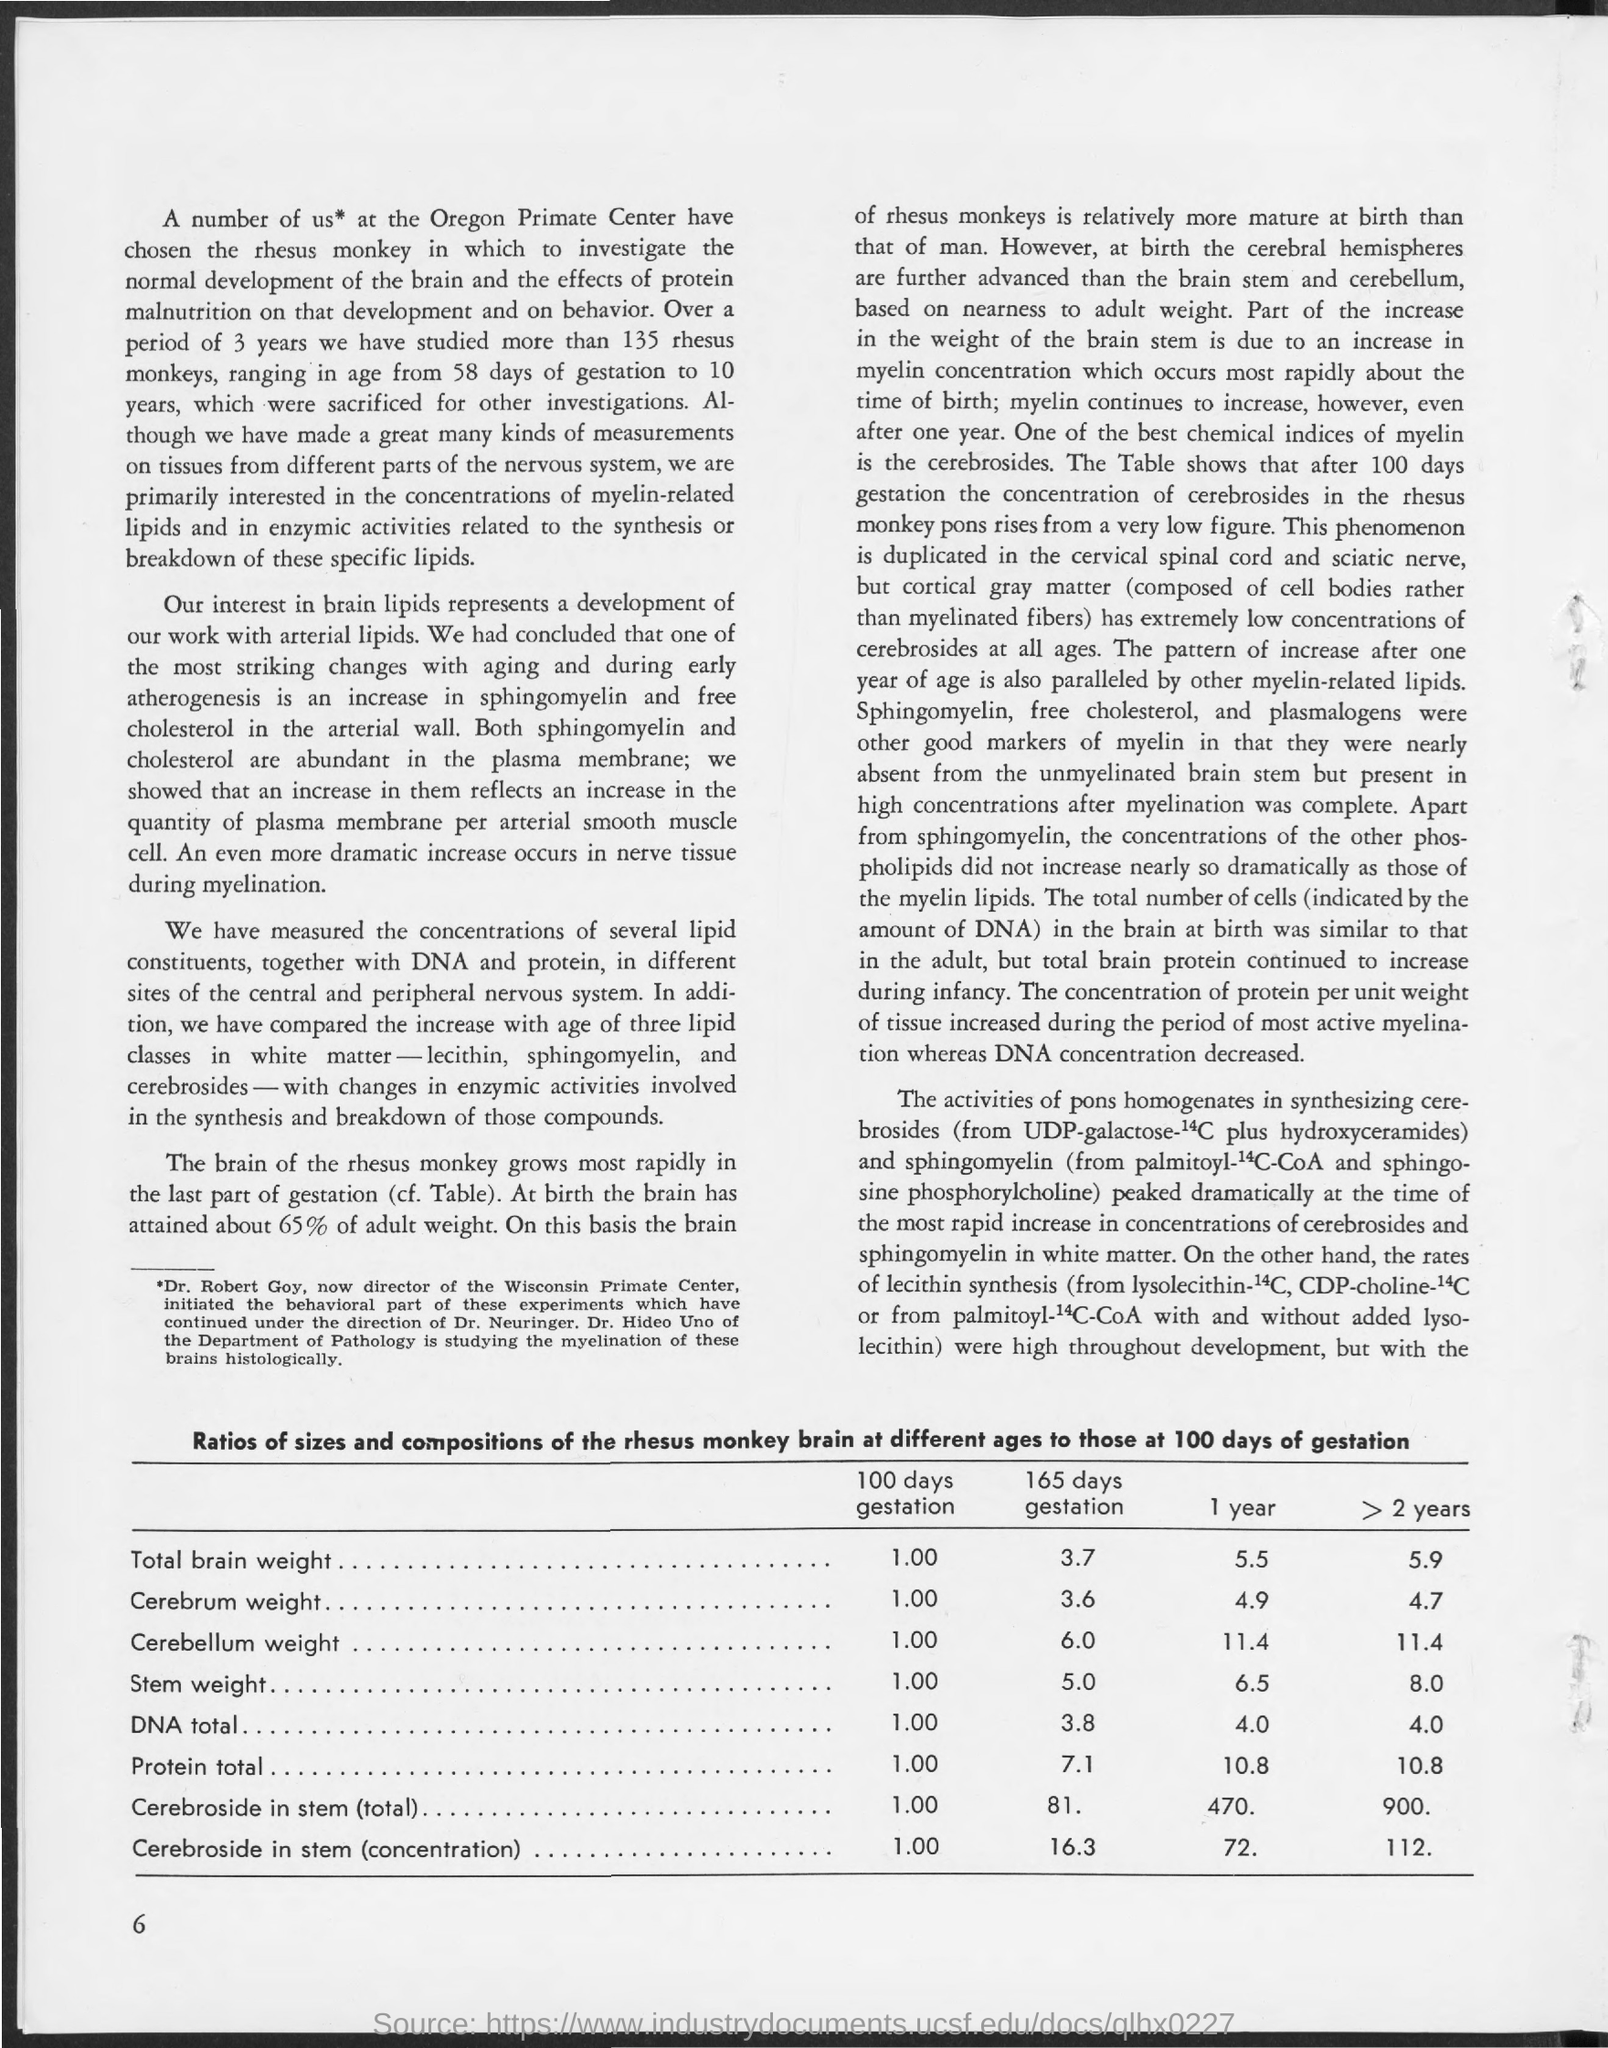How many Rhesus monkeys have been studied ?
Your response must be concise. 135. What was the period of the study?
Your answer should be compact. 3 years. What is Total Brain Weight for 100 days gestation?
Provide a short and direct response. 1.00. What is Total Brain Weight for 165 days gestation?
Provide a short and direct response. 3.7. What is Total Brain Weight for 1 year gestation?
Your answer should be compact. 5.5. What is Total Brain Weight for > 2 Years gestation?
Offer a terse response. 5.9. What is Cerebrum Weight for 100 days gestation?
Your answer should be compact. 1.00. What is Cerebrum Weight for 165 days gestation?
Keep it short and to the point. 3.6. What is Cerebrum Weight for 1 year gestation?
Your answer should be very brief. 4.9. What is Cerebrum Weight for > 2 Years gestation?
Make the answer very short. 4.7. 